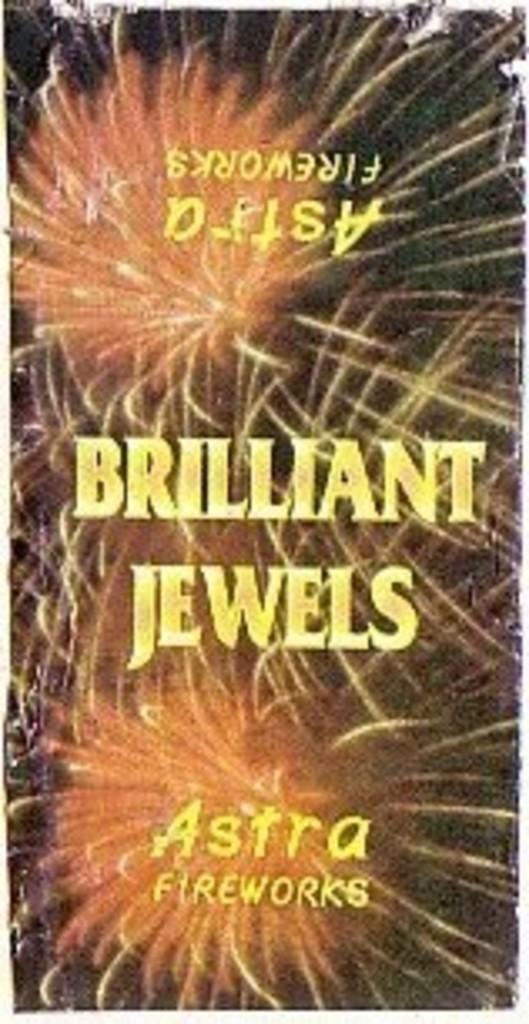Is astra the name of a company that makes fireworks?
Give a very brief answer. Yes. 